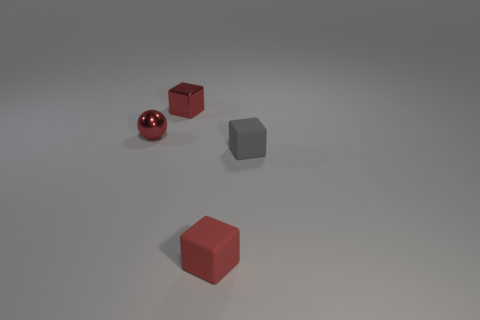Subtract all tiny red blocks. How many blocks are left? 1 Subtract 3 blocks. How many blocks are left? 0 Add 2 shiny objects. How many objects exist? 6 Subtract all gray cubes. How many cubes are left? 2 Subtract all cubes. How many objects are left? 1 Subtract 0 purple blocks. How many objects are left? 4 Subtract all brown cubes. Subtract all gray balls. How many cubes are left? 3 Subtract all red cylinders. How many brown blocks are left? 0 Subtract all brown metal objects. Subtract all tiny gray rubber blocks. How many objects are left? 3 Add 3 metallic blocks. How many metallic blocks are left? 4 